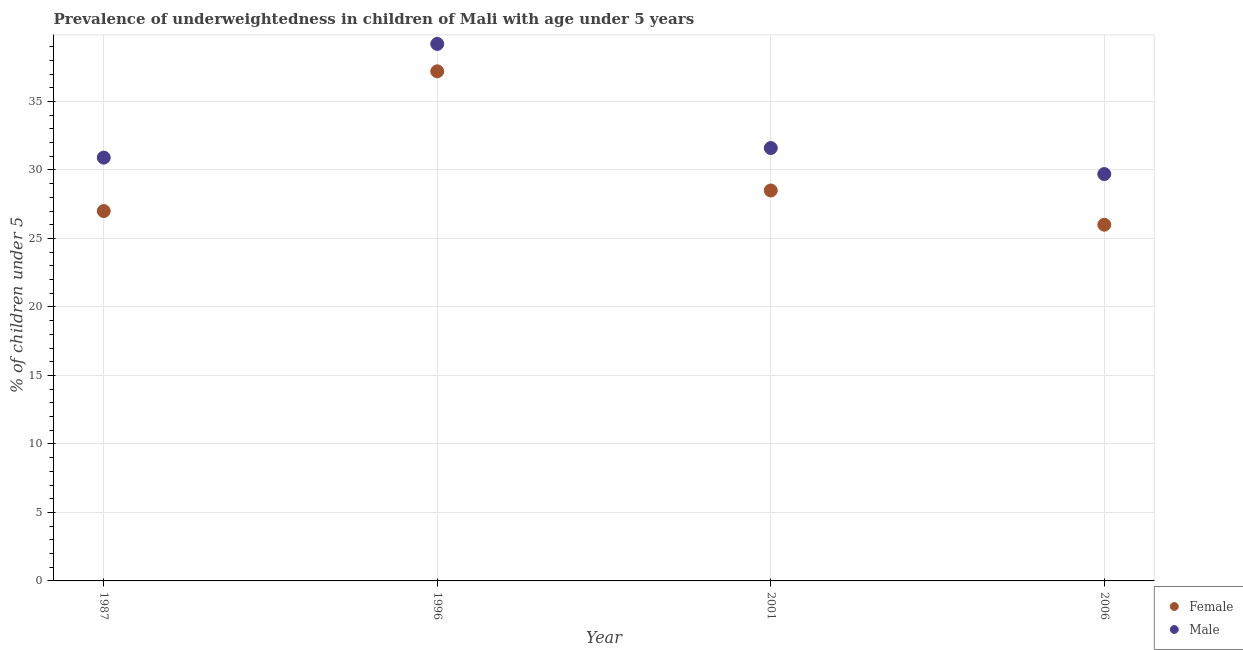How many different coloured dotlines are there?
Your response must be concise. 2. Is the number of dotlines equal to the number of legend labels?
Provide a short and direct response. Yes. What is the percentage of underweighted female children in 1987?
Ensure brevity in your answer.  27. Across all years, what is the maximum percentage of underweighted female children?
Offer a very short reply. 37.2. Across all years, what is the minimum percentage of underweighted male children?
Ensure brevity in your answer.  29.7. In which year was the percentage of underweighted male children minimum?
Offer a very short reply. 2006. What is the total percentage of underweighted female children in the graph?
Keep it short and to the point. 118.7. What is the difference between the percentage of underweighted male children in 1987 and the percentage of underweighted female children in 2001?
Offer a very short reply. 2.4. What is the average percentage of underweighted female children per year?
Make the answer very short. 29.68. In the year 2001, what is the difference between the percentage of underweighted female children and percentage of underweighted male children?
Your response must be concise. -3.1. In how many years, is the percentage of underweighted male children greater than 28 %?
Provide a short and direct response. 4. What is the ratio of the percentage of underweighted female children in 1996 to that in 2006?
Provide a short and direct response. 1.43. Is the percentage of underweighted female children in 1996 less than that in 2006?
Provide a succinct answer. No. What is the difference between the highest and the second highest percentage of underweighted female children?
Your response must be concise. 8.7. What is the difference between the highest and the lowest percentage of underweighted male children?
Your answer should be very brief. 9.5. Does the percentage of underweighted male children monotonically increase over the years?
Provide a short and direct response. No. Is the percentage of underweighted male children strictly greater than the percentage of underweighted female children over the years?
Offer a terse response. Yes. Is the percentage of underweighted male children strictly less than the percentage of underweighted female children over the years?
Offer a terse response. No. How many years are there in the graph?
Your answer should be compact. 4. What is the difference between two consecutive major ticks on the Y-axis?
Provide a succinct answer. 5. Does the graph contain grids?
Offer a terse response. Yes. Where does the legend appear in the graph?
Your answer should be very brief. Bottom right. What is the title of the graph?
Make the answer very short. Prevalence of underweightedness in children of Mali with age under 5 years. What is the label or title of the Y-axis?
Make the answer very short.  % of children under 5. What is the  % of children under 5 in Male in 1987?
Keep it short and to the point. 30.9. What is the  % of children under 5 of Female in 1996?
Make the answer very short. 37.2. What is the  % of children under 5 of Male in 1996?
Provide a short and direct response. 39.2. What is the  % of children under 5 in Female in 2001?
Ensure brevity in your answer.  28.5. What is the  % of children under 5 of Male in 2001?
Give a very brief answer. 31.6. What is the  % of children under 5 in Female in 2006?
Give a very brief answer. 26. What is the  % of children under 5 in Male in 2006?
Your answer should be very brief. 29.7. Across all years, what is the maximum  % of children under 5 of Female?
Your answer should be very brief. 37.2. Across all years, what is the maximum  % of children under 5 of Male?
Your answer should be compact. 39.2. Across all years, what is the minimum  % of children under 5 of Male?
Offer a very short reply. 29.7. What is the total  % of children under 5 of Female in the graph?
Offer a very short reply. 118.7. What is the total  % of children under 5 in Male in the graph?
Your answer should be very brief. 131.4. What is the difference between the  % of children under 5 in Female in 1987 and that in 1996?
Your response must be concise. -10.2. What is the difference between the  % of children under 5 of Male in 1987 and that in 1996?
Give a very brief answer. -8.3. What is the difference between the  % of children under 5 in Male in 1987 and that in 2001?
Offer a terse response. -0.7. What is the difference between the  % of children under 5 of Male in 1987 and that in 2006?
Your response must be concise. 1.2. What is the difference between the  % of children under 5 of Male in 1996 and that in 2001?
Make the answer very short. 7.6. What is the difference between the  % of children under 5 of Female in 1996 and that in 2006?
Provide a short and direct response. 11.2. What is the difference between the  % of children under 5 of Female in 2001 and that in 2006?
Make the answer very short. 2.5. What is the difference between the  % of children under 5 in Male in 2001 and that in 2006?
Offer a very short reply. 1.9. What is the difference between the  % of children under 5 in Female in 1987 and the  % of children under 5 in Male in 1996?
Give a very brief answer. -12.2. What is the difference between the  % of children under 5 of Female in 1987 and the  % of children under 5 of Male in 2001?
Keep it short and to the point. -4.6. What is the difference between the  % of children under 5 in Female in 1987 and the  % of children under 5 in Male in 2006?
Offer a terse response. -2.7. What is the difference between the  % of children under 5 of Female in 1996 and the  % of children under 5 of Male in 2001?
Make the answer very short. 5.6. What is the average  % of children under 5 in Female per year?
Ensure brevity in your answer.  29.68. What is the average  % of children under 5 of Male per year?
Provide a succinct answer. 32.85. In the year 1987, what is the difference between the  % of children under 5 of Female and  % of children under 5 of Male?
Provide a succinct answer. -3.9. In the year 1996, what is the difference between the  % of children under 5 of Female and  % of children under 5 of Male?
Your answer should be very brief. -2. What is the ratio of the  % of children under 5 of Female in 1987 to that in 1996?
Ensure brevity in your answer.  0.73. What is the ratio of the  % of children under 5 of Male in 1987 to that in 1996?
Your answer should be compact. 0.79. What is the ratio of the  % of children under 5 of Female in 1987 to that in 2001?
Provide a short and direct response. 0.95. What is the ratio of the  % of children under 5 of Male in 1987 to that in 2001?
Your answer should be compact. 0.98. What is the ratio of the  % of children under 5 of Male in 1987 to that in 2006?
Ensure brevity in your answer.  1.04. What is the ratio of the  % of children under 5 of Female in 1996 to that in 2001?
Offer a very short reply. 1.31. What is the ratio of the  % of children under 5 of Male in 1996 to that in 2001?
Your answer should be very brief. 1.24. What is the ratio of the  % of children under 5 of Female in 1996 to that in 2006?
Give a very brief answer. 1.43. What is the ratio of the  % of children under 5 of Male in 1996 to that in 2006?
Give a very brief answer. 1.32. What is the ratio of the  % of children under 5 of Female in 2001 to that in 2006?
Provide a succinct answer. 1.1. What is the ratio of the  % of children under 5 of Male in 2001 to that in 2006?
Your response must be concise. 1.06. What is the difference between the highest and the second highest  % of children under 5 of Female?
Provide a short and direct response. 8.7. What is the difference between the highest and the second highest  % of children under 5 of Male?
Keep it short and to the point. 7.6. 